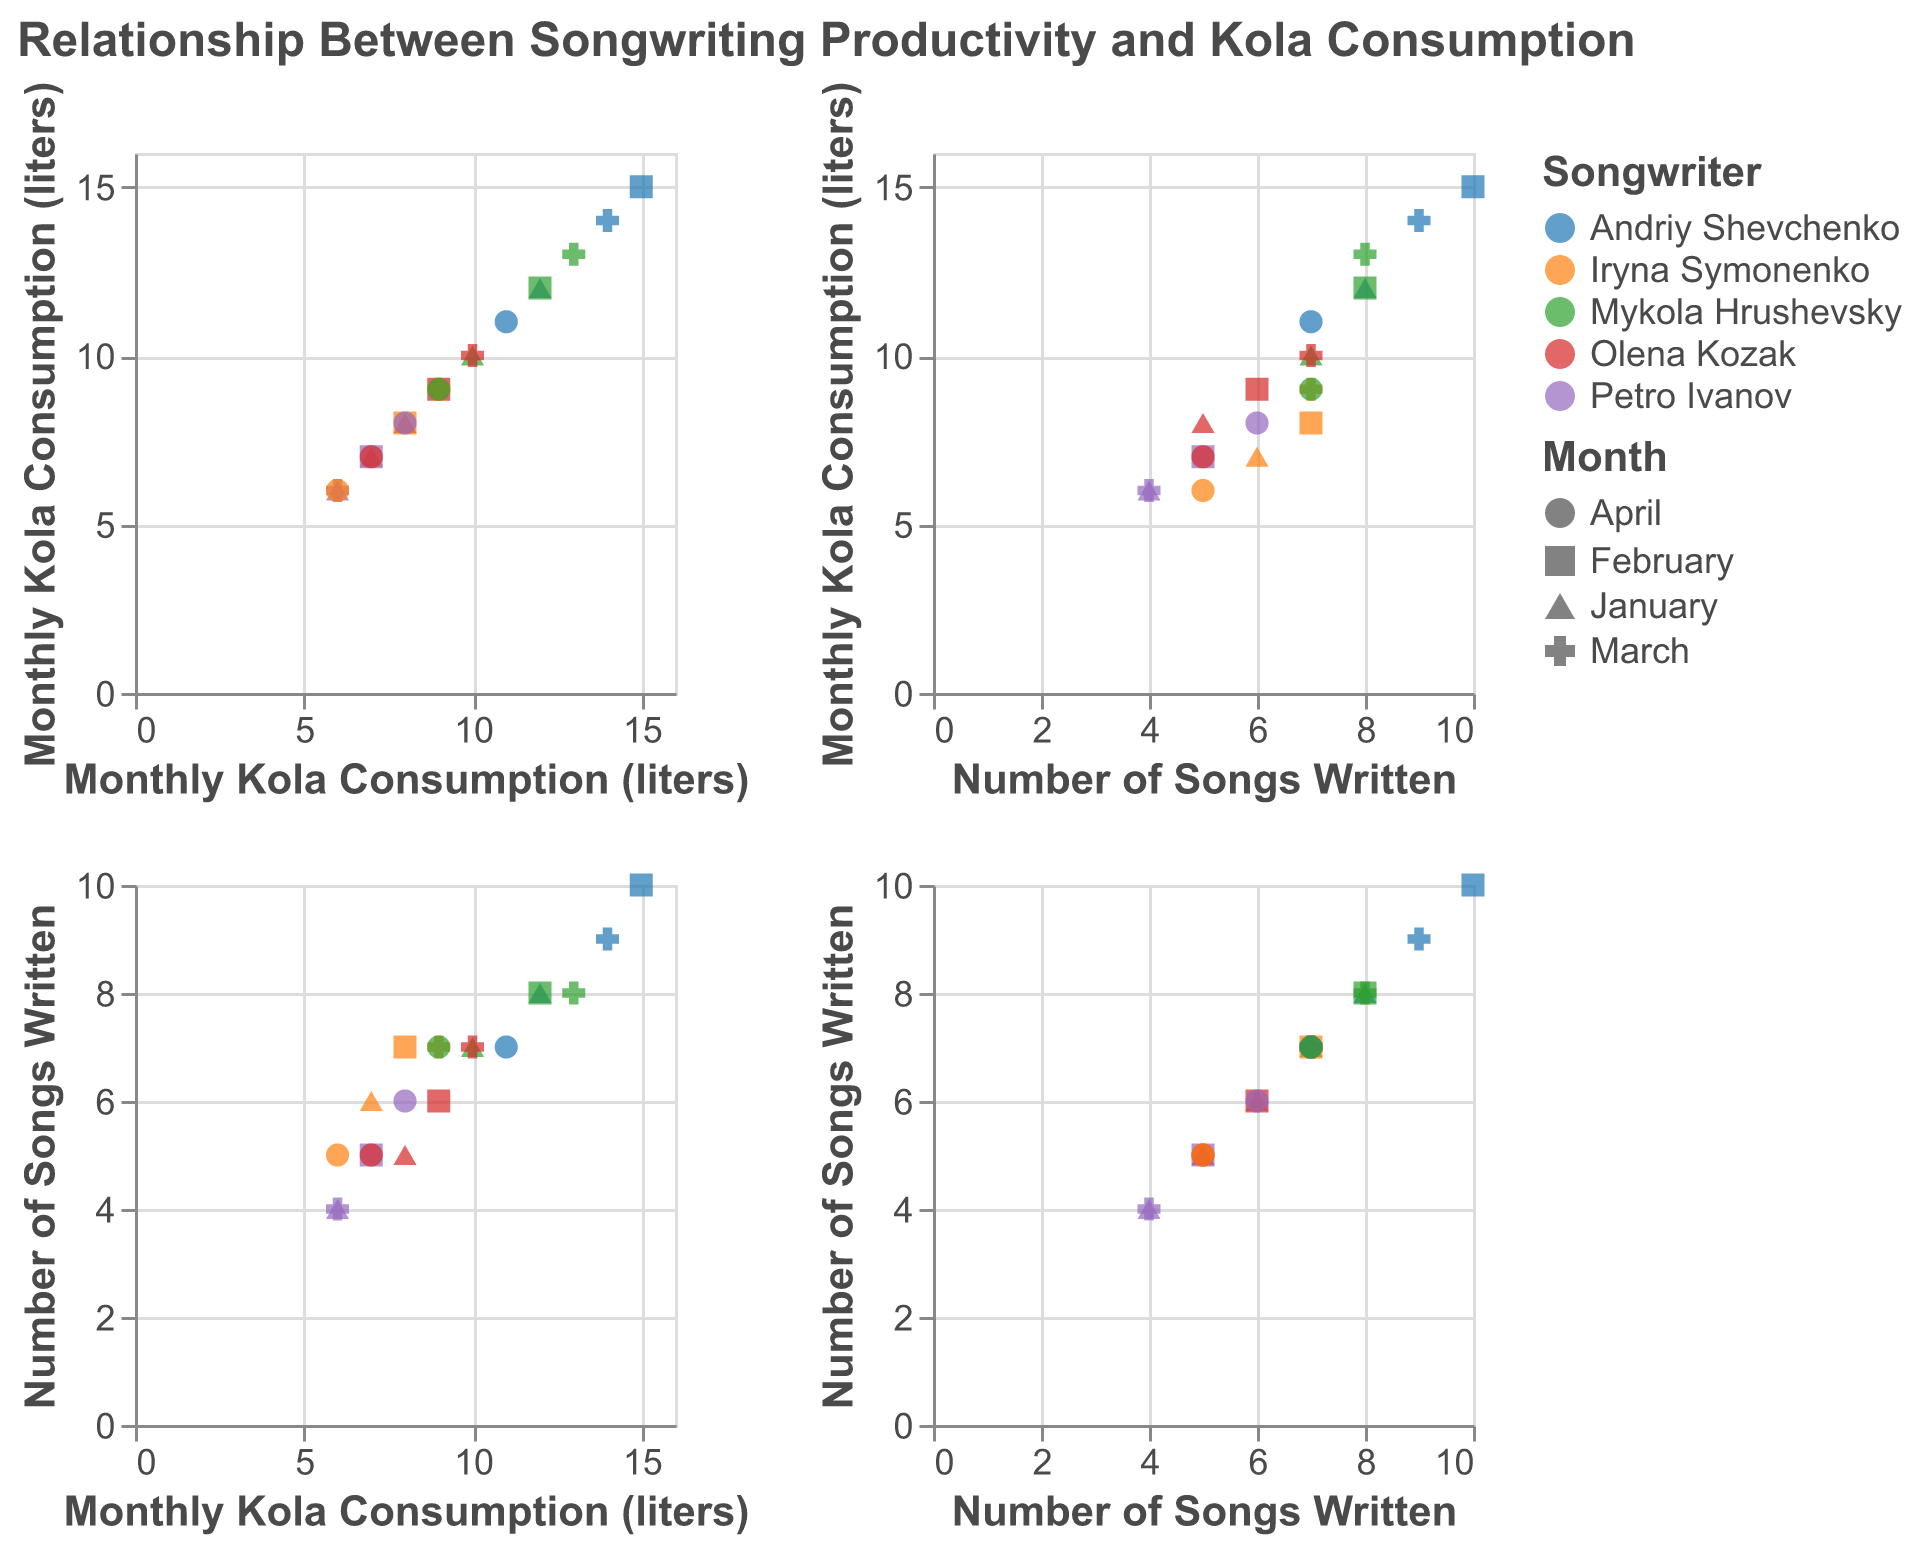What is the title of the scatter plot matrix? The title is the text displayed prominently at the top of the figure. The title reads "Relationship Between Songwriting Productivity and Kola Consumption".
Answer: Relationship Between Songwriting Productivity and Kola Consumption How many data points are plotted in total? The total number of data points is the sum of all individual points in the scatter plot matrix. There are 20 data points, representing four months (January to April) and five songwriters.
Answer: 20 Which songwriter had the highest monthly Kola consumption, and how many songs did they write in that month? The highest Kola consumption can be found by looking for the data point with the maximum value on the "Monthly Kola Consumption (liters)" axis. In February, Andriy Shevchenko consumed 15 liters and wrote 10 songs.
Answer: Andriy Shevchenko, 10 songs In which month did Olena Kozak have the lowest number of songs written and what was her Kola consumption that month? To find the lowest number of songs written, search for Olena Kozak across the months and identify the minimum "Number of Songs Written". In January, Olena Kozak wrote 5 songs with an 8-liter consumption.
Answer: January, 8 liters What's the average number of songs written in March? Sum the number of songs written in March and divide by the number of songwriters. The data points in March are (9, 7, 8, 7, 4) adding up to 35. Dividing by 5 songwriters gives an average of 7.
Answer: 7 Comparing January and April, did Mykola Hrushevsky's Kola consumption increase or decrease, and by how much? Find the Kola consumption for Mykola Hrushevsky in January and April, subtract April's value from January's to determine the change. Mykola Hrushevsky consumed 10 liters in January and 9 liters in April. The decrease is 10 - 9 = 1 liter.
Answer: Decreased by 1 liter Is there a positive correlation between Kola consumption and the number of songs written? By observing the scatter plots where "Monthly Kola Consumption (liters)" is on one axis and "Number of Songs Written" is on the other, we notice that higher kola consumption often coincides with a higher number of songs written.
Answer: Yes, generally Which month shows the highest variability in Kola consumption among songwriters? Variability can be seen from the spread and range of data points in the "Monthly Kola Consumption (liters)" axis for each month. February has the highest spread in Kola consumption, from 7 liters to 15 liters.
Answer: February What is the range of Petro Ivanov's Kola consumption across all months? Petro Ivanov's Kola consumption values are extracted from the data: 6, 7, 6, and 8 liters. The range is calculated by subtracting the minimum value from the maximum value, 8 - 6 = 2 liters.
Answer: 2 liters Which songwriter shows the most consistent number of songs written regardless of the month? Consistency can be identified by checking if the number of songs written by each songwriter varies little across months. Iryna Symonenko consistently wrote 6 to 7 songs each month.
Answer: Iryna Symonenko 